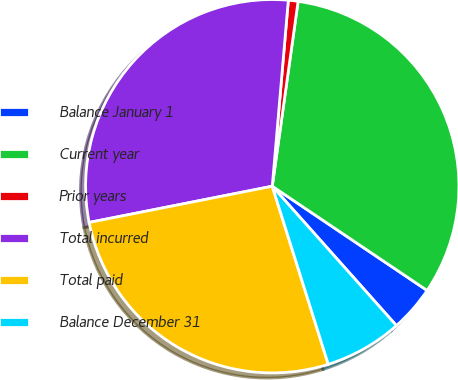<chart> <loc_0><loc_0><loc_500><loc_500><pie_chart><fcel>Balance January 1<fcel>Current year<fcel>Prior years<fcel>Total incurred<fcel>Total paid<fcel>Balance December 31<nl><fcel>3.99%<fcel>32.22%<fcel>0.84%<fcel>29.48%<fcel>26.74%<fcel>6.73%<nl></chart> 